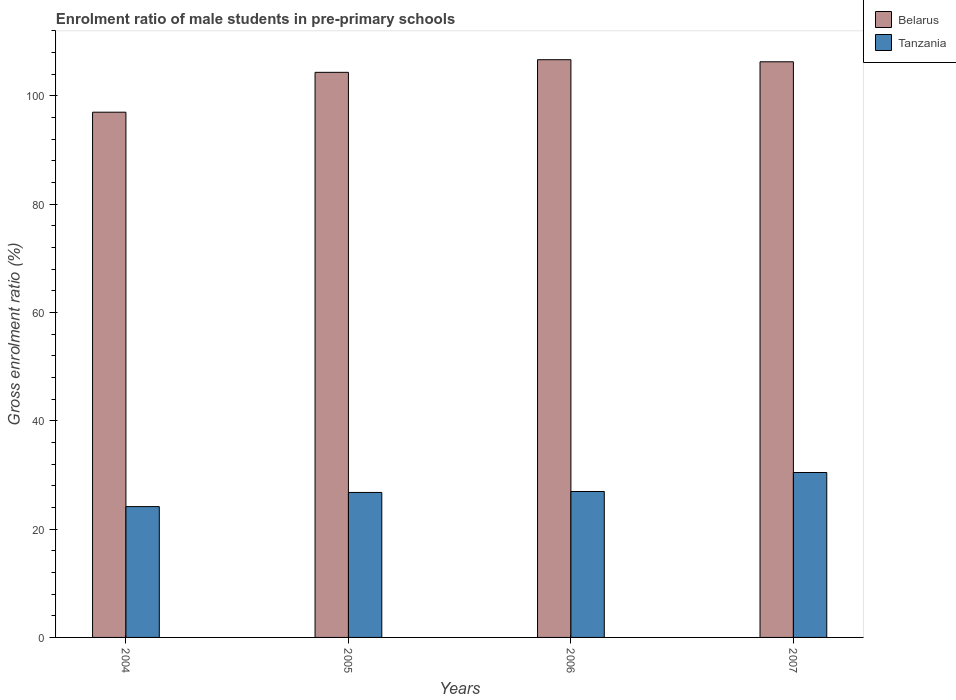How many different coloured bars are there?
Offer a terse response. 2. Are the number of bars per tick equal to the number of legend labels?
Keep it short and to the point. Yes. How many bars are there on the 2nd tick from the left?
Offer a very short reply. 2. How many bars are there on the 1st tick from the right?
Provide a succinct answer. 2. In how many cases, is the number of bars for a given year not equal to the number of legend labels?
Your answer should be compact. 0. What is the enrolment ratio of male students in pre-primary schools in Tanzania in 2004?
Your response must be concise. 24.16. Across all years, what is the maximum enrolment ratio of male students in pre-primary schools in Tanzania?
Provide a short and direct response. 30.45. Across all years, what is the minimum enrolment ratio of male students in pre-primary schools in Tanzania?
Your response must be concise. 24.16. In which year was the enrolment ratio of male students in pre-primary schools in Belarus minimum?
Give a very brief answer. 2004. What is the total enrolment ratio of male students in pre-primary schools in Belarus in the graph?
Offer a terse response. 414.29. What is the difference between the enrolment ratio of male students in pre-primary schools in Belarus in 2004 and that in 2007?
Your answer should be very brief. -9.31. What is the difference between the enrolment ratio of male students in pre-primary schools in Belarus in 2007 and the enrolment ratio of male students in pre-primary schools in Tanzania in 2004?
Your answer should be compact. 82.13. What is the average enrolment ratio of male students in pre-primary schools in Belarus per year?
Ensure brevity in your answer.  103.57. In the year 2004, what is the difference between the enrolment ratio of male students in pre-primary schools in Tanzania and enrolment ratio of male students in pre-primary schools in Belarus?
Give a very brief answer. -72.83. In how many years, is the enrolment ratio of male students in pre-primary schools in Belarus greater than 68 %?
Make the answer very short. 4. What is the ratio of the enrolment ratio of male students in pre-primary schools in Belarus in 2005 to that in 2006?
Provide a short and direct response. 0.98. Is the difference between the enrolment ratio of male students in pre-primary schools in Tanzania in 2005 and 2007 greater than the difference between the enrolment ratio of male students in pre-primary schools in Belarus in 2005 and 2007?
Offer a terse response. No. What is the difference between the highest and the second highest enrolment ratio of male students in pre-primary schools in Tanzania?
Your response must be concise. 3.5. What is the difference between the highest and the lowest enrolment ratio of male students in pre-primary schools in Tanzania?
Make the answer very short. 6.3. In how many years, is the enrolment ratio of male students in pre-primary schools in Tanzania greater than the average enrolment ratio of male students in pre-primary schools in Tanzania taken over all years?
Offer a terse response. 1. Is the sum of the enrolment ratio of male students in pre-primary schools in Belarus in 2006 and 2007 greater than the maximum enrolment ratio of male students in pre-primary schools in Tanzania across all years?
Make the answer very short. Yes. What does the 2nd bar from the left in 2004 represents?
Make the answer very short. Tanzania. What does the 1st bar from the right in 2004 represents?
Offer a terse response. Tanzania. Are all the bars in the graph horizontal?
Give a very brief answer. No. How many years are there in the graph?
Your answer should be compact. 4. Does the graph contain any zero values?
Provide a short and direct response. No. Where does the legend appear in the graph?
Make the answer very short. Top right. How are the legend labels stacked?
Offer a very short reply. Vertical. What is the title of the graph?
Make the answer very short. Enrolment ratio of male students in pre-primary schools. Does "Bangladesh" appear as one of the legend labels in the graph?
Provide a succinct answer. No. What is the label or title of the X-axis?
Keep it short and to the point. Years. What is the Gross enrolment ratio (%) of Belarus in 2004?
Provide a short and direct response. 96.98. What is the Gross enrolment ratio (%) of Tanzania in 2004?
Offer a very short reply. 24.16. What is the Gross enrolment ratio (%) of Belarus in 2005?
Keep it short and to the point. 104.34. What is the Gross enrolment ratio (%) in Tanzania in 2005?
Keep it short and to the point. 26.77. What is the Gross enrolment ratio (%) in Belarus in 2006?
Offer a very short reply. 106.67. What is the Gross enrolment ratio (%) in Tanzania in 2006?
Make the answer very short. 26.95. What is the Gross enrolment ratio (%) in Belarus in 2007?
Provide a short and direct response. 106.29. What is the Gross enrolment ratio (%) of Tanzania in 2007?
Your answer should be very brief. 30.45. Across all years, what is the maximum Gross enrolment ratio (%) in Belarus?
Give a very brief answer. 106.67. Across all years, what is the maximum Gross enrolment ratio (%) of Tanzania?
Provide a succinct answer. 30.45. Across all years, what is the minimum Gross enrolment ratio (%) of Belarus?
Your answer should be very brief. 96.98. Across all years, what is the minimum Gross enrolment ratio (%) in Tanzania?
Your answer should be very brief. 24.16. What is the total Gross enrolment ratio (%) in Belarus in the graph?
Provide a short and direct response. 414.29. What is the total Gross enrolment ratio (%) of Tanzania in the graph?
Provide a short and direct response. 108.32. What is the difference between the Gross enrolment ratio (%) of Belarus in 2004 and that in 2005?
Provide a short and direct response. -7.36. What is the difference between the Gross enrolment ratio (%) of Tanzania in 2004 and that in 2005?
Provide a succinct answer. -2.62. What is the difference between the Gross enrolment ratio (%) in Belarus in 2004 and that in 2006?
Make the answer very short. -9.69. What is the difference between the Gross enrolment ratio (%) of Tanzania in 2004 and that in 2006?
Your answer should be compact. -2.79. What is the difference between the Gross enrolment ratio (%) of Belarus in 2004 and that in 2007?
Make the answer very short. -9.31. What is the difference between the Gross enrolment ratio (%) in Tanzania in 2004 and that in 2007?
Offer a very short reply. -6.3. What is the difference between the Gross enrolment ratio (%) of Belarus in 2005 and that in 2006?
Offer a terse response. -2.33. What is the difference between the Gross enrolment ratio (%) of Tanzania in 2005 and that in 2006?
Ensure brevity in your answer.  -0.18. What is the difference between the Gross enrolment ratio (%) of Belarus in 2005 and that in 2007?
Your answer should be compact. -1.95. What is the difference between the Gross enrolment ratio (%) of Tanzania in 2005 and that in 2007?
Keep it short and to the point. -3.68. What is the difference between the Gross enrolment ratio (%) of Belarus in 2006 and that in 2007?
Your response must be concise. 0.38. What is the difference between the Gross enrolment ratio (%) in Tanzania in 2006 and that in 2007?
Give a very brief answer. -3.5. What is the difference between the Gross enrolment ratio (%) of Belarus in 2004 and the Gross enrolment ratio (%) of Tanzania in 2005?
Keep it short and to the point. 70.21. What is the difference between the Gross enrolment ratio (%) in Belarus in 2004 and the Gross enrolment ratio (%) in Tanzania in 2006?
Your response must be concise. 70.04. What is the difference between the Gross enrolment ratio (%) of Belarus in 2004 and the Gross enrolment ratio (%) of Tanzania in 2007?
Keep it short and to the point. 66.53. What is the difference between the Gross enrolment ratio (%) in Belarus in 2005 and the Gross enrolment ratio (%) in Tanzania in 2006?
Make the answer very short. 77.39. What is the difference between the Gross enrolment ratio (%) of Belarus in 2005 and the Gross enrolment ratio (%) of Tanzania in 2007?
Your response must be concise. 73.89. What is the difference between the Gross enrolment ratio (%) in Belarus in 2006 and the Gross enrolment ratio (%) in Tanzania in 2007?
Offer a very short reply. 76.22. What is the average Gross enrolment ratio (%) in Belarus per year?
Offer a terse response. 103.57. What is the average Gross enrolment ratio (%) in Tanzania per year?
Your answer should be compact. 27.08. In the year 2004, what is the difference between the Gross enrolment ratio (%) of Belarus and Gross enrolment ratio (%) of Tanzania?
Offer a terse response. 72.83. In the year 2005, what is the difference between the Gross enrolment ratio (%) of Belarus and Gross enrolment ratio (%) of Tanzania?
Ensure brevity in your answer.  77.57. In the year 2006, what is the difference between the Gross enrolment ratio (%) in Belarus and Gross enrolment ratio (%) in Tanzania?
Make the answer very short. 79.73. In the year 2007, what is the difference between the Gross enrolment ratio (%) of Belarus and Gross enrolment ratio (%) of Tanzania?
Provide a short and direct response. 75.84. What is the ratio of the Gross enrolment ratio (%) in Belarus in 2004 to that in 2005?
Your answer should be compact. 0.93. What is the ratio of the Gross enrolment ratio (%) in Tanzania in 2004 to that in 2005?
Provide a succinct answer. 0.9. What is the ratio of the Gross enrolment ratio (%) of Belarus in 2004 to that in 2006?
Give a very brief answer. 0.91. What is the ratio of the Gross enrolment ratio (%) in Tanzania in 2004 to that in 2006?
Offer a terse response. 0.9. What is the ratio of the Gross enrolment ratio (%) of Belarus in 2004 to that in 2007?
Your answer should be compact. 0.91. What is the ratio of the Gross enrolment ratio (%) in Tanzania in 2004 to that in 2007?
Your answer should be very brief. 0.79. What is the ratio of the Gross enrolment ratio (%) of Belarus in 2005 to that in 2006?
Offer a very short reply. 0.98. What is the ratio of the Gross enrolment ratio (%) of Tanzania in 2005 to that in 2006?
Offer a terse response. 0.99. What is the ratio of the Gross enrolment ratio (%) in Belarus in 2005 to that in 2007?
Give a very brief answer. 0.98. What is the ratio of the Gross enrolment ratio (%) in Tanzania in 2005 to that in 2007?
Give a very brief answer. 0.88. What is the ratio of the Gross enrolment ratio (%) of Belarus in 2006 to that in 2007?
Provide a short and direct response. 1. What is the ratio of the Gross enrolment ratio (%) of Tanzania in 2006 to that in 2007?
Ensure brevity in your answer.  0.88. What is the difference between the highest and the second highest Gross enrolment ratio (%) in Belarus?
Your answer should be very brief. 0.38. What is the difference between the highest and the second highest Gross enrolment ratio (%) in Tanzania?
Make the answer very short. 3.5. What is the difference between the highest and the lowest Gross enrolment ratio (%) in Belarus?
Your response must be concise. 9.69. What is the difference between the highest and the lowest Gross enrolment ratio (%) of Tanzania?
Provide a succinct answer. 6.3. 